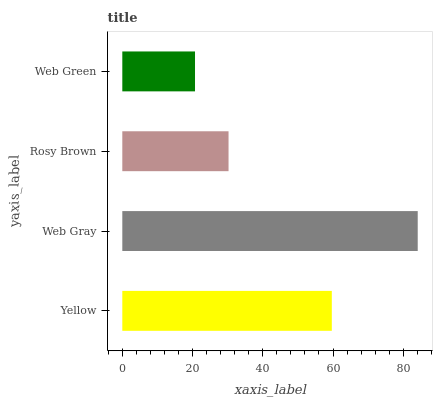Is Web Green the minimum?
Answer yes or no. Yes. Is Web Gray the maximum?
Answer yes or no. Yes. Is Rosy Brown the minimum?
Answer yes or no. No. Is Rosy Brown the maximum?
Answer yes or no. No. Is Web Gray greater than Rosy Brown?
Answer yes or no. Yes. Is Rosy Brown less than Web Gray?
Answer yes or no. Yes. Is Rosy Brown greater than Web Gray?
Answer yes or no. No. Is Web Gray less than Rosy Brown?
Answer yes or no. No. Is Yellow the high median?
Answer yes or no. Yes. Is Rosy Brown the low median?
Answer yes or no. Yes. Is Web Gray the high median?
Answer yes or no. No. Is Yellow the low median?
Answer yes or no. No. 